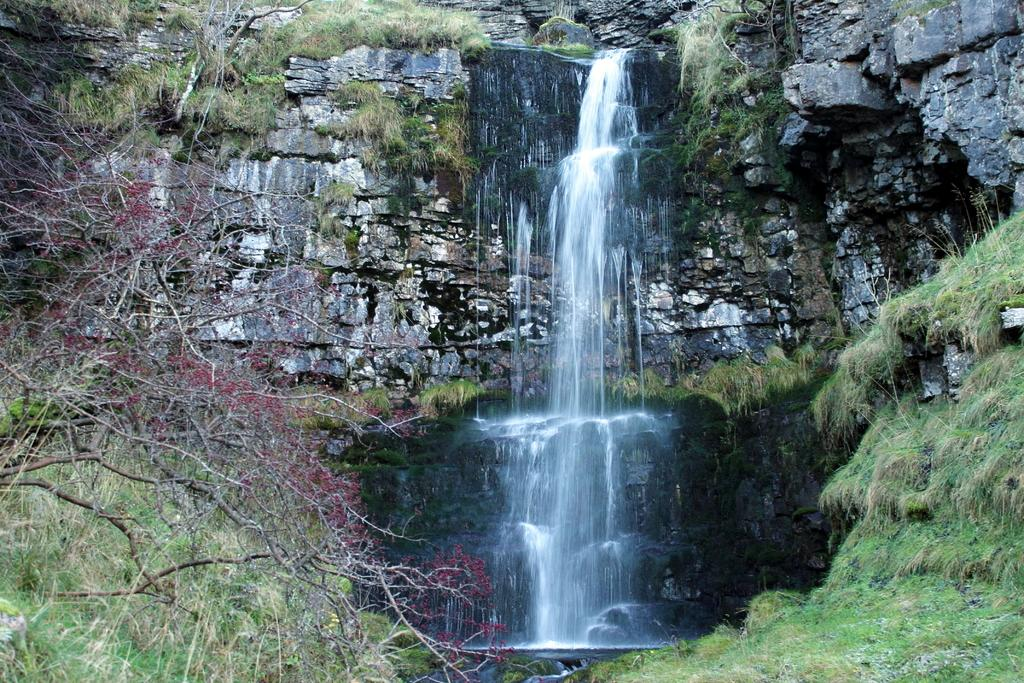What natural feature is the main subject of the image? There is a waterfall in the image. What type of vegetation can be seen in the image? There are trees, plants, and flowers in the image. What geological feature is present in the image? There is a rock wall in the image. What type of jelly can be seen on the rock wall in the image? There is no jelly present on the rock wall in the image. What type of work is being done by the waterfall in the image? The waterfall is a natural feature and does not perform any work in the image. 